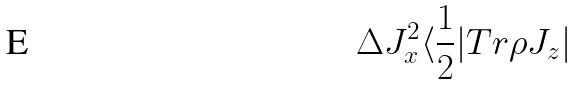<formula> <loc_0><loc_0><loc_500><loc_500>\Delta J _ { x } ^ { 2 } \langle \frac { 1 } { 2 } | T r \rho J _ { z } |</formula> 